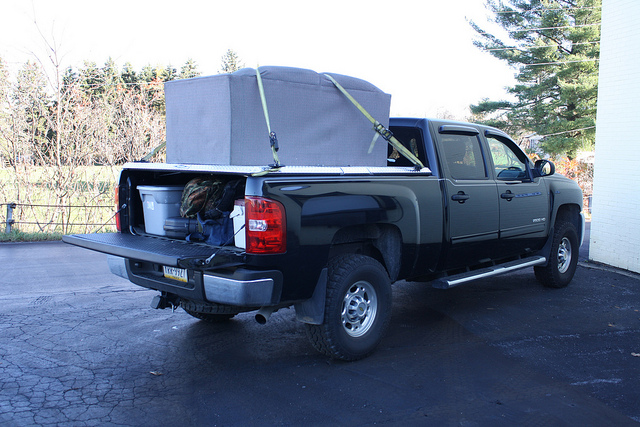<image>What picture is on the back of the truck? There is no picture on the back of the truck. What picture is on the back of the truck? I am not sure what picture is on the back of the truck. It can be none or there might be a picture that I cannot see. 